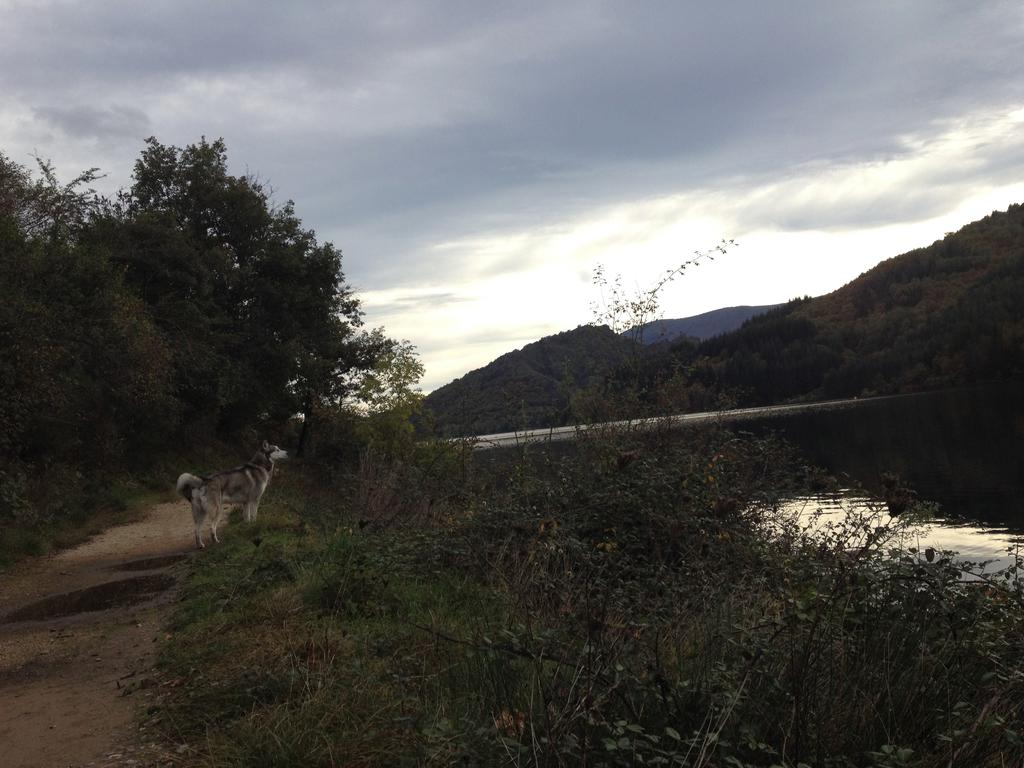What type of natural landscape is depicted in the image? The image features mountains, trees, and water. Can you describe the dog in the image? The dog in the image is white and black in color. What is the color of the sky in the image? The sky is white and blue in color. Where is the canvas located in the image? There is no canvas present in the image. What type of meeting is taking place in the image? There is no meeting depicted in the image. 